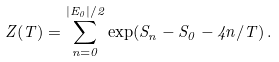<formula> <loc_0><loc_0><loc_500><loc_500>Z ( T ) = \sum _ { n = 0 } ^ { | E _ { 0 } | / 2 } \exp ( S _ { n } - S _ { 0 } - 4 n / T ) \, .</formula> 